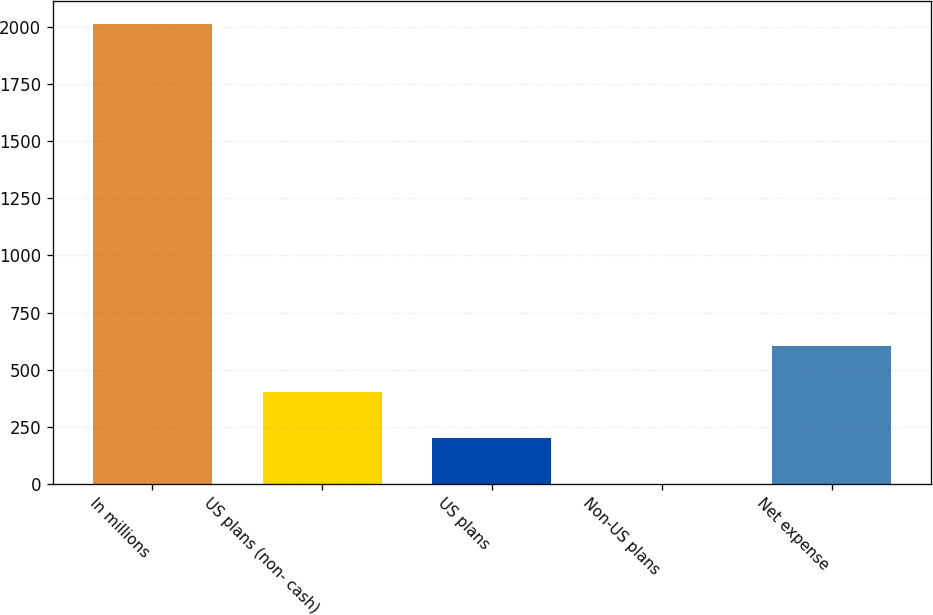Convert chart to OTSL. <chart><loc_0><loc_0><loc_500><loc_500><bar_chart><fcel>In millions<fcel>US plans (non- cash)<fcel>US plans<fcel>Non-US plans<fcel>Net expense<nl><fcel>2011<fcel>403.8<fcel>202.9<fcel>2<fcel>604.7<nl></chart> 